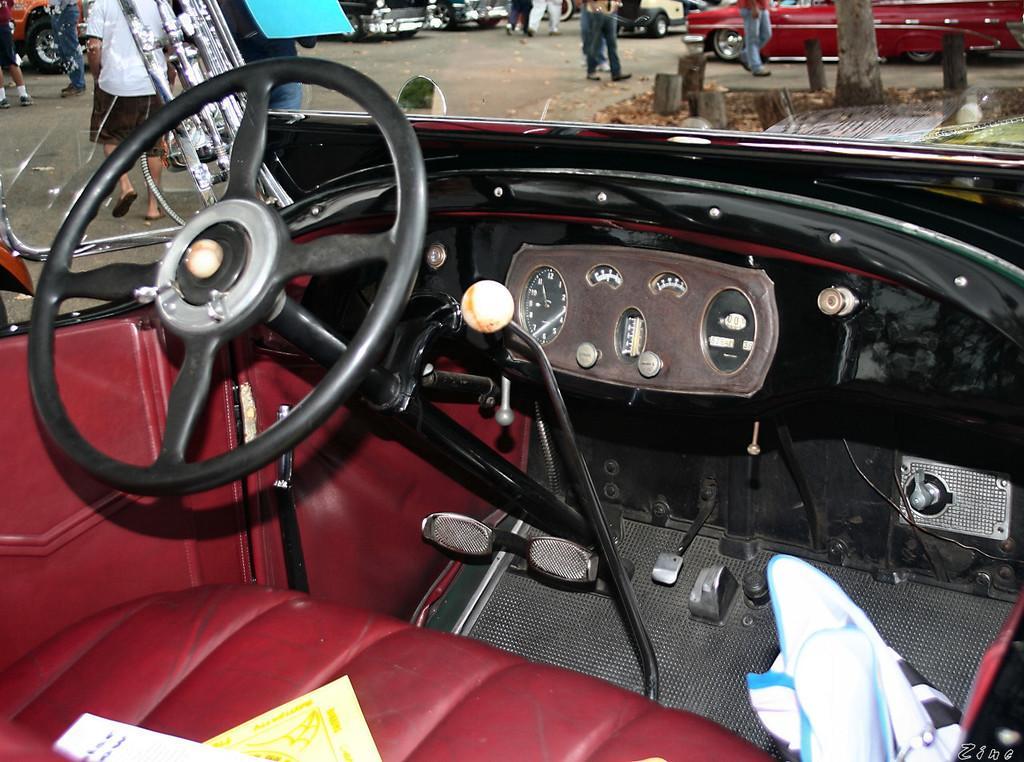Can you describe this image briefly? Here I can see a red color car. At the bottom of the image I can see few papers on the seat. On the left side there is a steering. In the background I can see few people and some vehicles on the road. On the top right side of the image there is a tree trunk. 